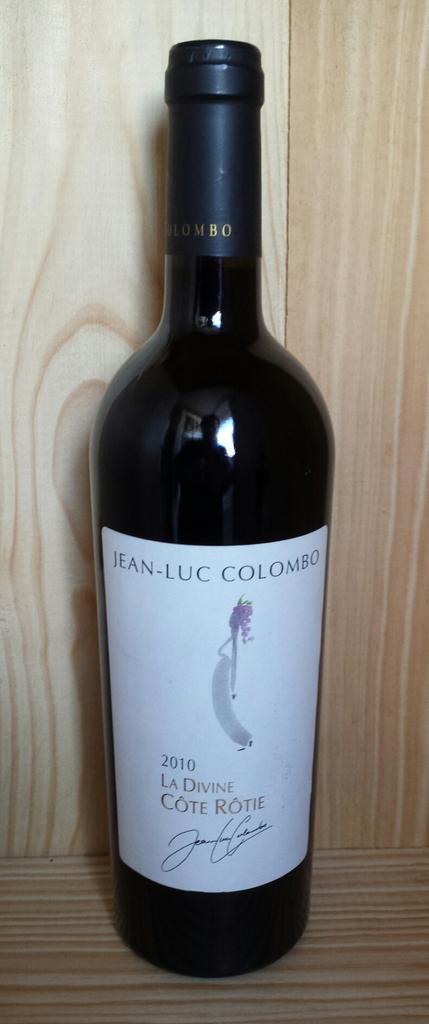What year was this wine bottled?
Your answer should be very brief. 2010. What is the name of the vineyard?
Ensure brevity in your answer.  Jean-luc colombo. 